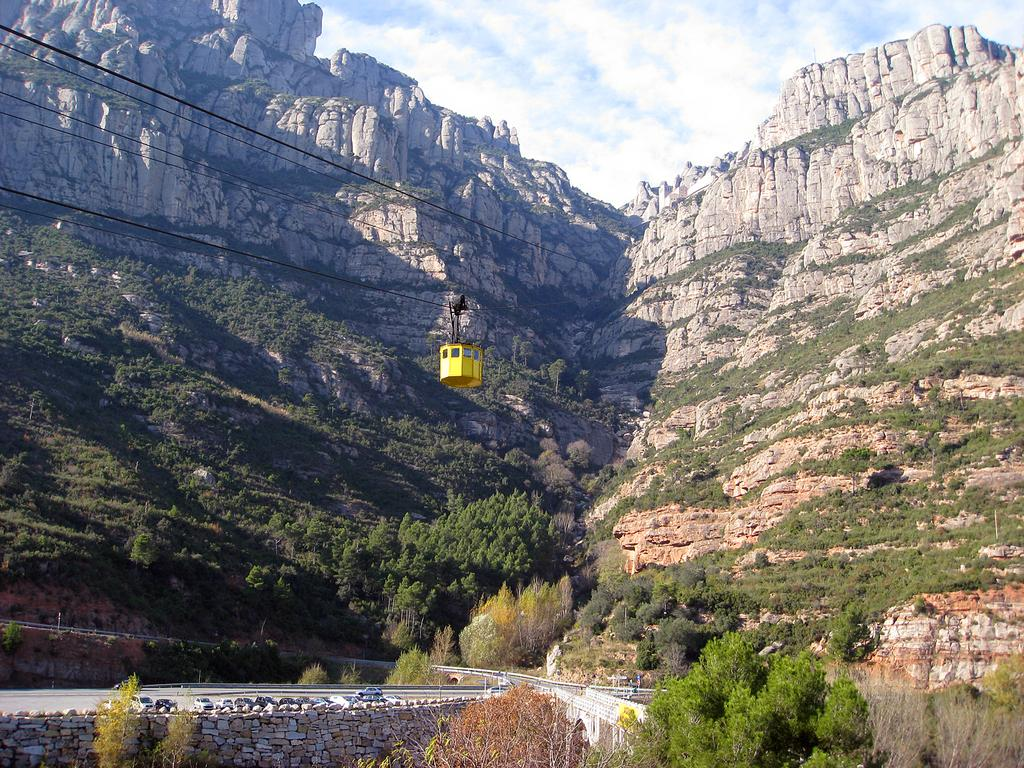What mode of transportation can be seen in the image? There is a cable car in the image. What type of vegetation is present in the image? There are trees with green color in the image. What geological features can be seen in the background of the image? There are rocks visible in the background of the image. What is the color of the sky in the image? The sky is blue and white in color. What type of pest can be seen crawling on the cable car in the image? There are no pests visible on the cable car in the image. What type of relation is depicted between the trees and rocks in the image? There is no relation depicted between the trees and rocks in the image; they are simply separate elements in the landscape. 